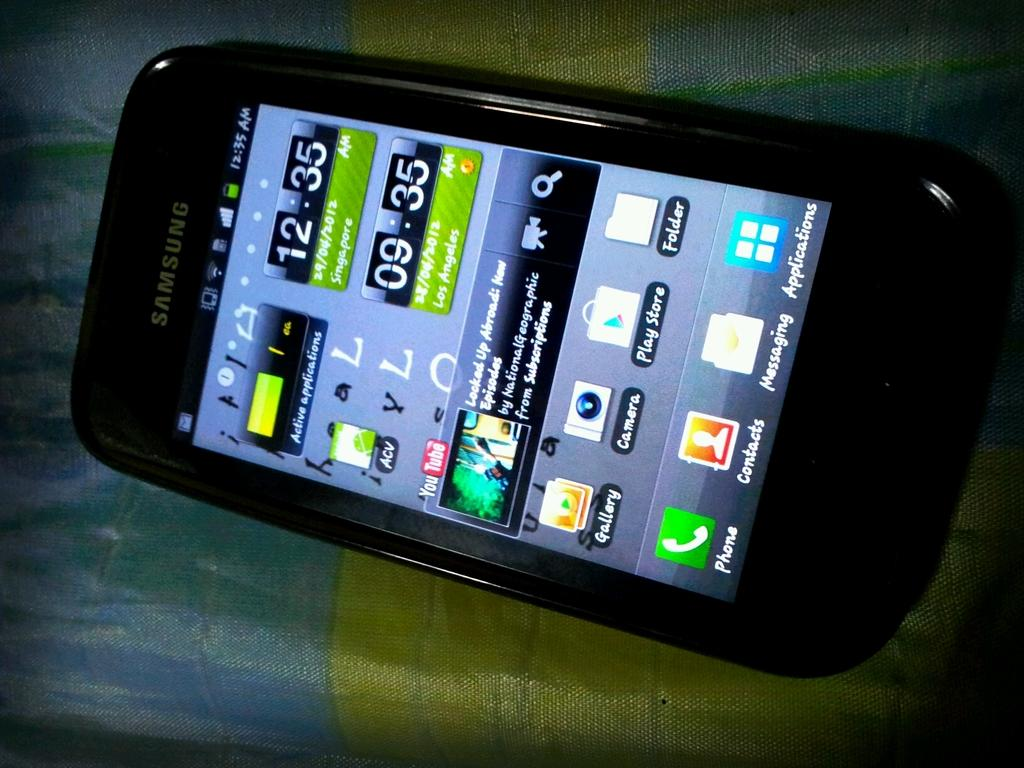<image>
Present a compact description of the photo's key features. A smasung phone shows the time in various zones along with other apps. 